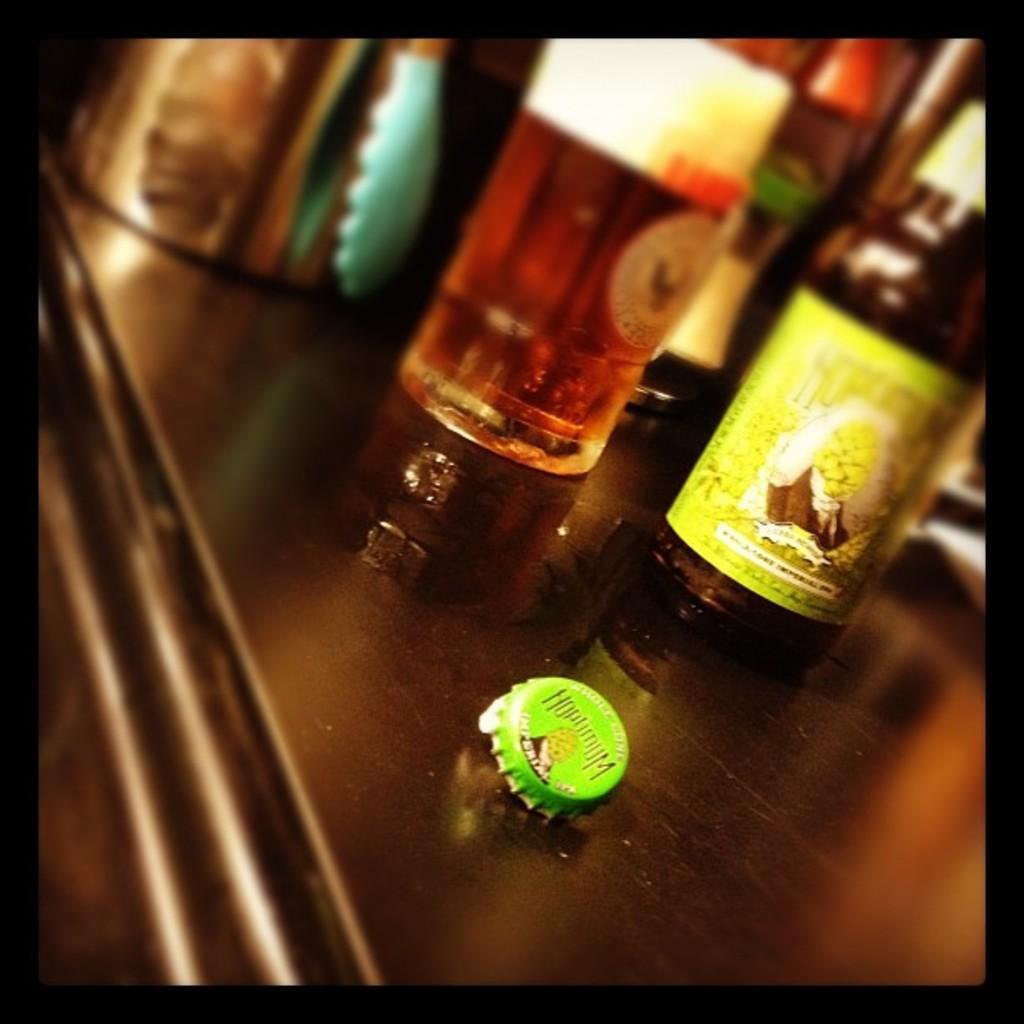Could you give a brief overview of what you see in this image? In this image, there is a table on which bottles are kept and a cap is kept. This image is taken inside a room. 